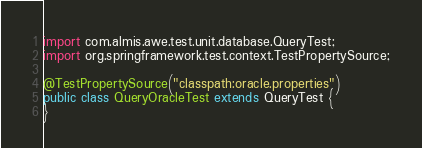<code> <loc_0><loc_0><loc_500><loc_500><_Java_>
import com.almis.awe.test.unit.database.QueryTest;
import org.springframework.test.context.TestPropertySource;

@TestPropertySource("classpath:oracle.properties")
public class QueryOracleTest extends QueryTest {
}
</code> 